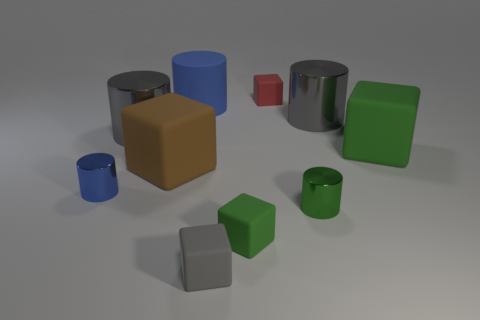There is a green rubber object to the right of the tiny red object; is its shape the same as the tiny object behind the blue matte cylinder? Yes, the green rubber object located to the right of the tiny red cube indeed shares the same geometric shape as the tiny cube situated behind the blue matte cylinder. Both exhibit the properties of a cube, characterized by their six equal square faces, edges of the same length, and ninety-degree angles at each corner. 